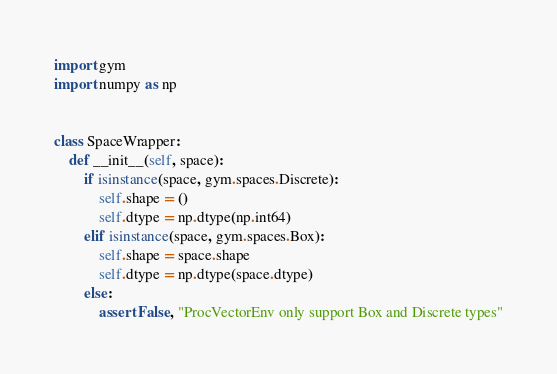<code> <loc_0><loc_0><loc_500><loc_500><_Python_>import gym
import numpy as np


class SpaceWrapper:
    def __init__(self, space):
        if isinstance(space, gym.spaces.Discrete):
            self.shape = ()
            self.dtype = np.dtype(np.int64)
        elif isinstance(space, gym.spaces.Box):
            self.shape = space.shape
            self.dtype = np.dtype(space.dtype)
        else:
            assert False, "ProcVectorEnv only support Box and Discrete types"
</code> 